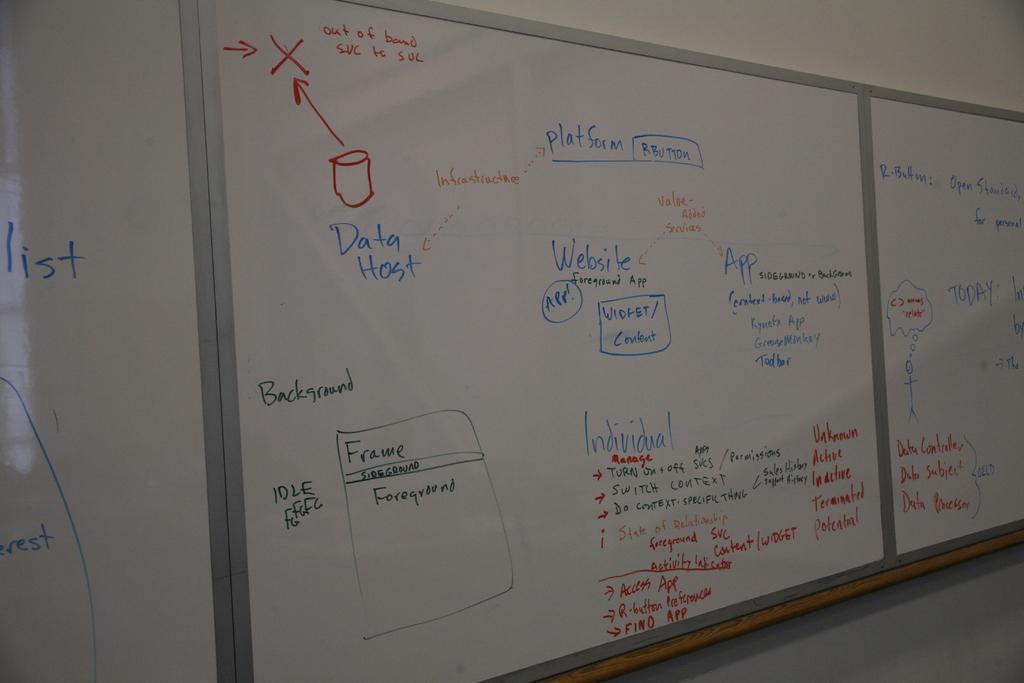Describe this image in one or two sentences. In this picture we can see many white classroom boards on the wall with something written on them. 